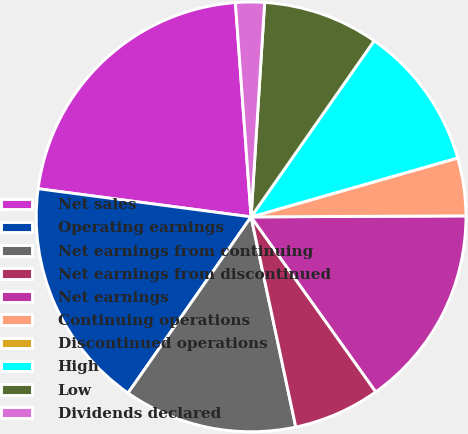Convert chart. <chart><loc_0><loc_0><loc_500><loc_500><pie_chart><fcel>Net sales<fcel>Operating earnings<fcel>Net earnings from continuing<fcel>Net earnings from discontinued<fcel>Net earnings<fcel>Continuing operations<fcel>Discontinued operations<fcel>High<fcel>Low<fcel>Dividends declared<nl><fcel>21.74%<fcel>17.39%<fcel>13.04%<fcel>6.52%<fcel>15.22%<fcel>4.35%<fcel>0.0%<fcel>10.87%<fcel>8.7%<fcel>2.17%<nl></chart> 